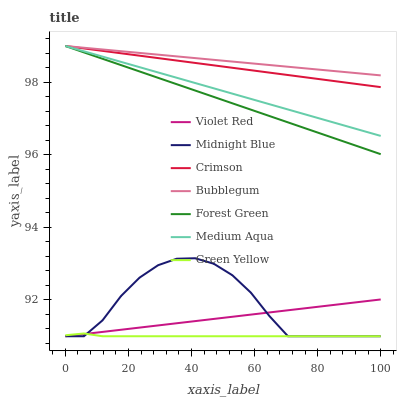Does Green Yellow have the minimum area under the curve?
Answer yes or no. Yes. Does Bubblegum have the maximum area under the curve?
Answer yes or no. Yes. Does Midnight Blue have the minimum area under the curve?
Answer yes or no. No. Does Midnight Blue have the maximum area under the curve?
Answer yes or no. No. Is Violet Red the smoothest?
Answer yes or no. Yes. Is Midnight Blue the roughest?
Answer yes or no. Yes. Is Bubblegum the smoothest?
Answer yes or no. No. Is Bubblegum the roughest?
Answer yes or no. No. Does Violet Red have the lowest value?
Answer yes or no. Yes. Does Bubblegum have the lowest value?
Answer yes or no. No. Does Crimson have the highest value?
Answer yes or no. Yes. Does Midnight Blue have the highest value?
Answer yes or no. No. Is Midnight Blue less than Medium Aqua?
Answer yes or no. Yes. Is Forest Green greater than Violet Red?
Answer yes or no. Yes. Does Bubblegum intersect Crimson?
Answer yes or no. Yes. Is Bubblegum less than Crimson?
Answer yes or no. No. Is Bubblegum greater than Crimson?
Answer yes or no. No. Does Midnight Blue intersect Medium Aqua?
Answer yes or no. No. 